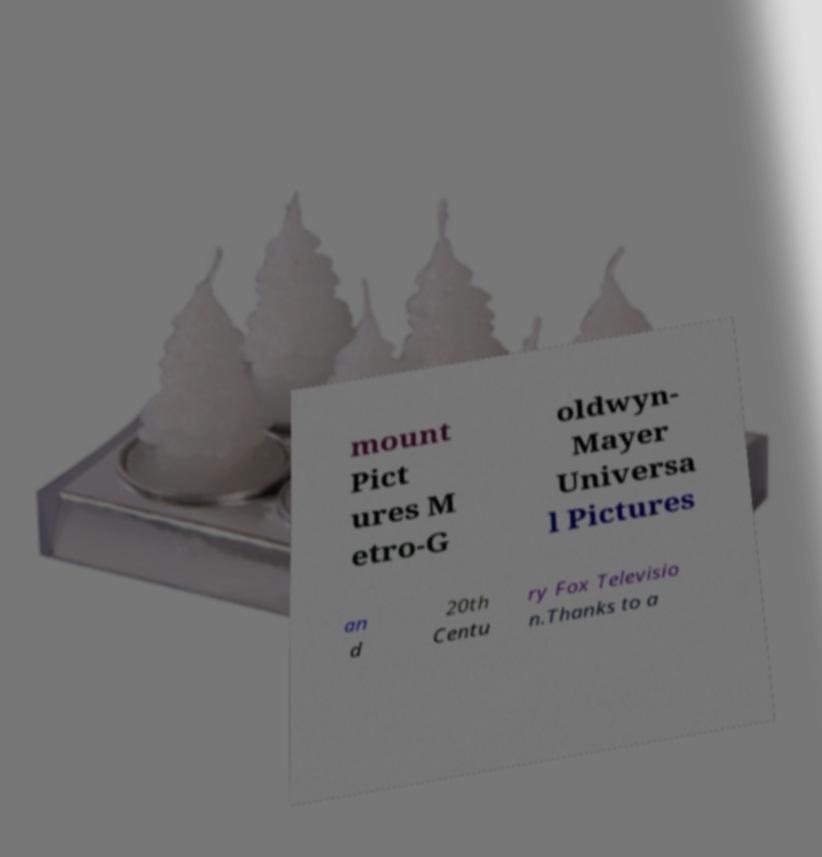Please read and relay the text visible in this image. What does it say? mount Pict ures M etro-G oldwyn- Mayer Universa l Pictures an d 20th Centu ry Fox Televisio n.Thanks to a 